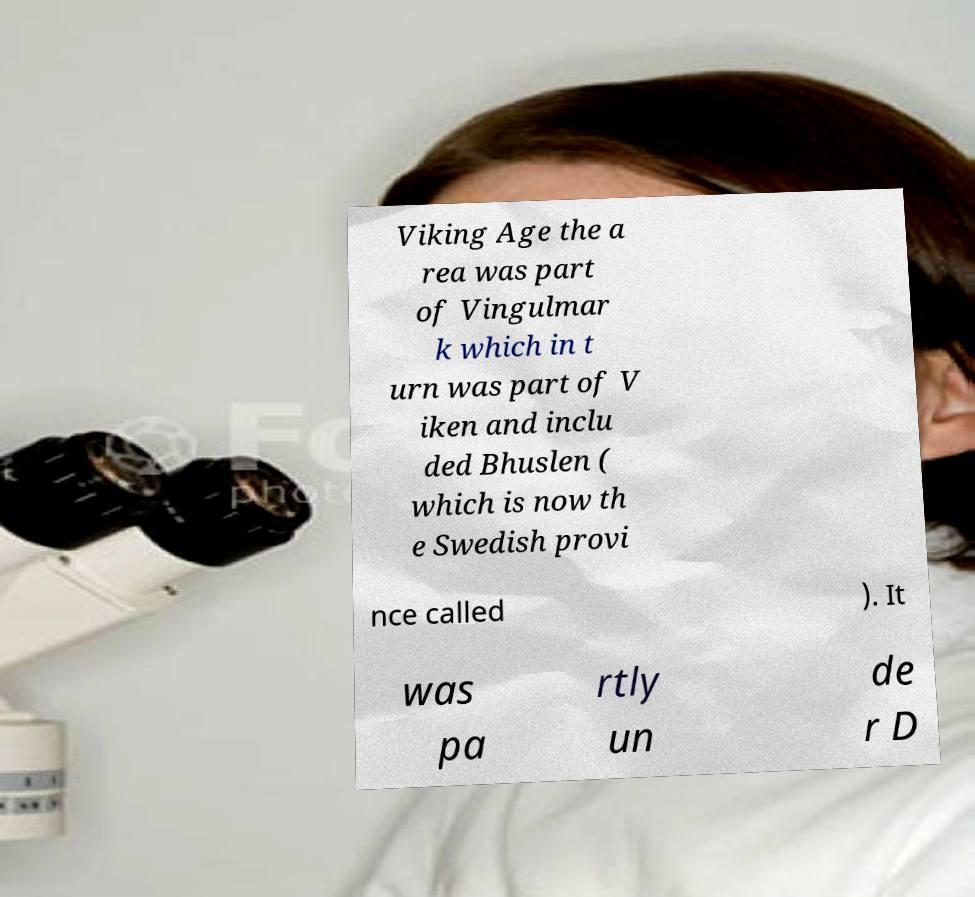Can you read and provide the text displayed in the image?This photo seems to have some interesting text. Can you extract and type it out for me? Viking Age the a rea was part of Vingulmar k which in t urn was part of V iken and inclu ded Bhuslen ( which is now th e Swedish provi nce called ). It was pa rtly un de r D 